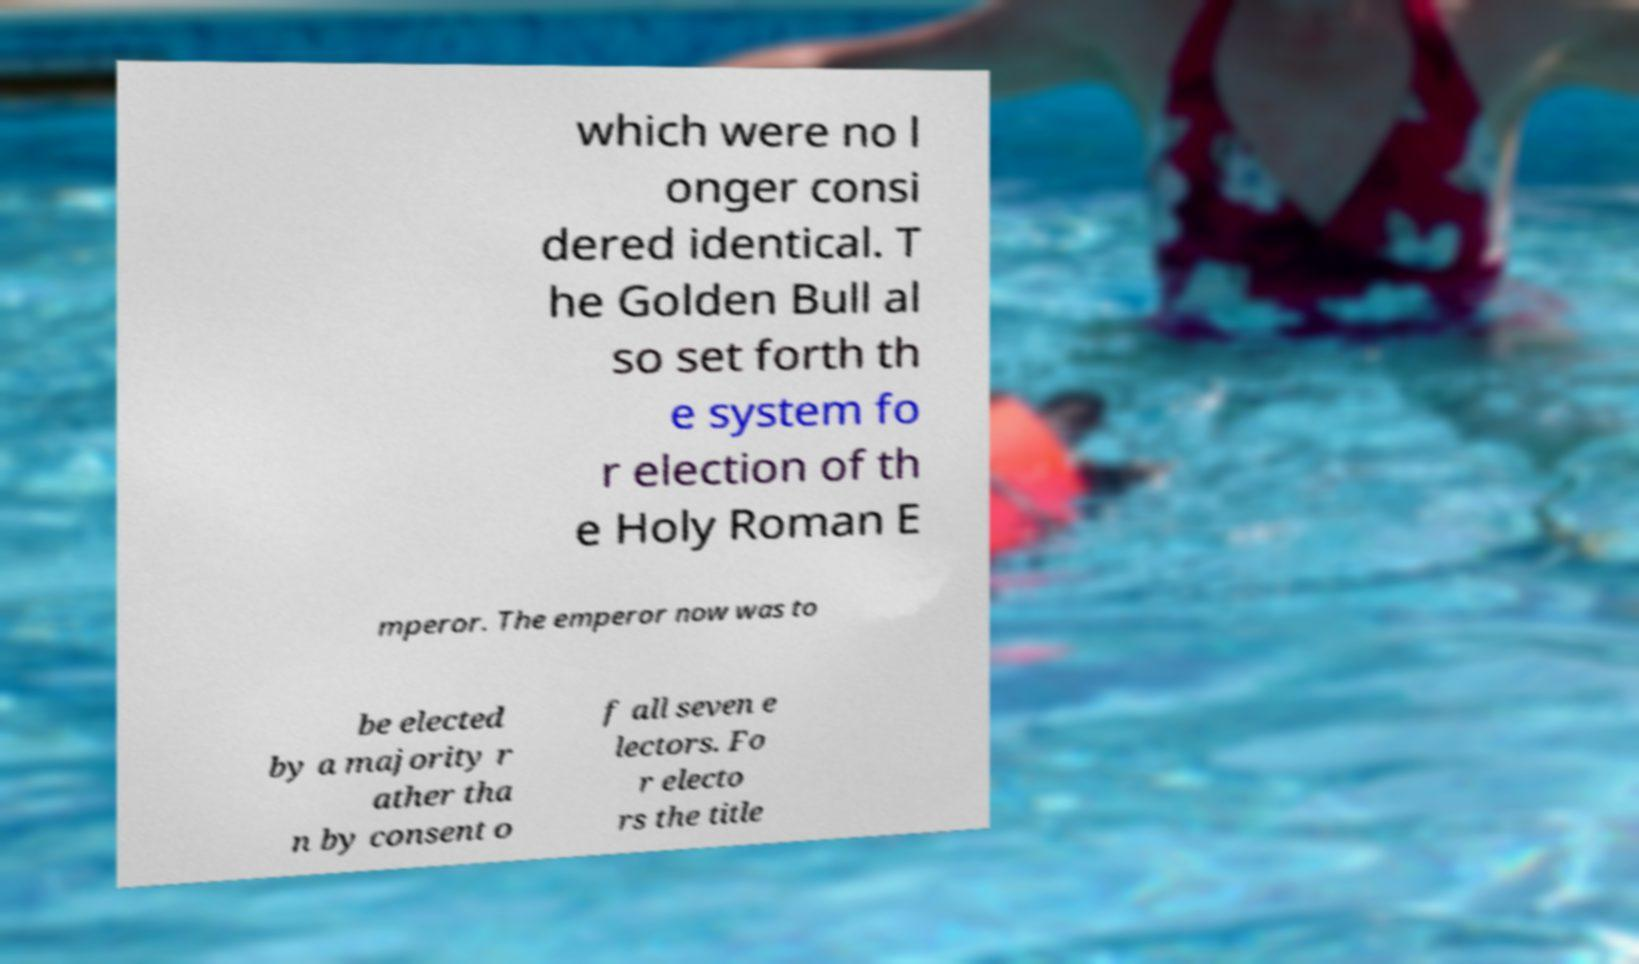Could you assist in decoding the text presented in this image and type it out clearly? which were no l onger consi dered identical. T he Golden Bull al so set forth th e system fo r election of th e Holy Roman E mperor. The emperor now was to be elected by a majority r ather tha n by consent o f all seven e lectors. Fo r electo rs the title 